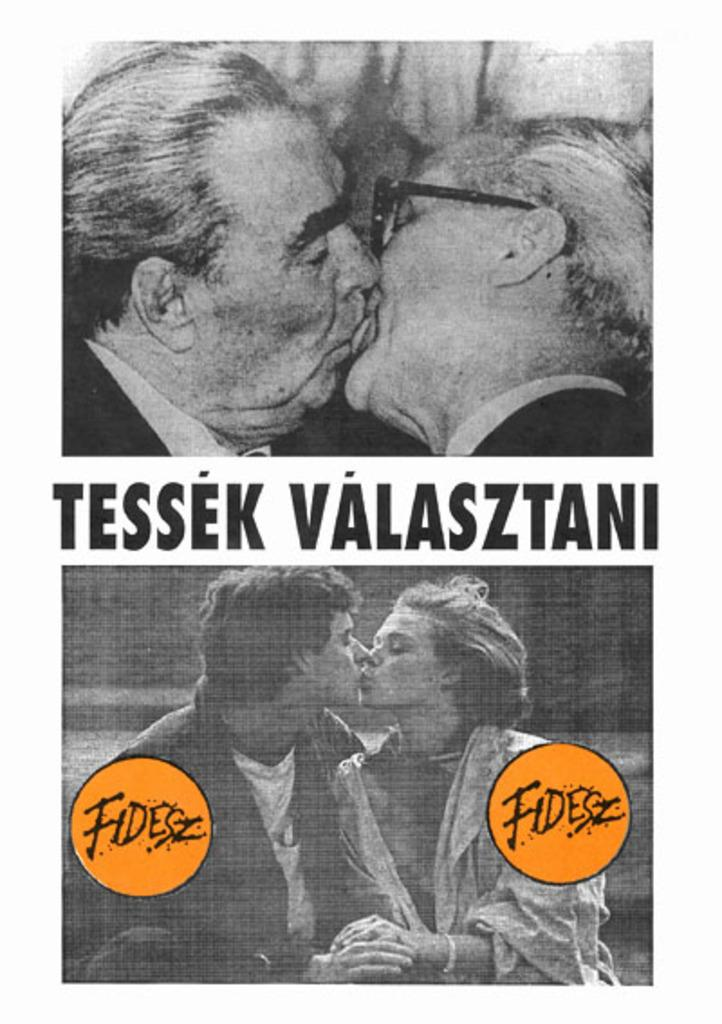How many people are in the image? There are two persons in the image. What are the two persons doing in the image? The two persons are sitting and kissing. Is there any text or writing visible in the image? Yes, there is text or writing visible in the image. What type of flesh can be seen in the image? There is no flesh visible in the image; it features two persons sitting and kissing. What kind of nerve is being stimulated by the scissors in the image? There are no scissors present in the image, so it is not possible to determine which nerve might be stimulated. 